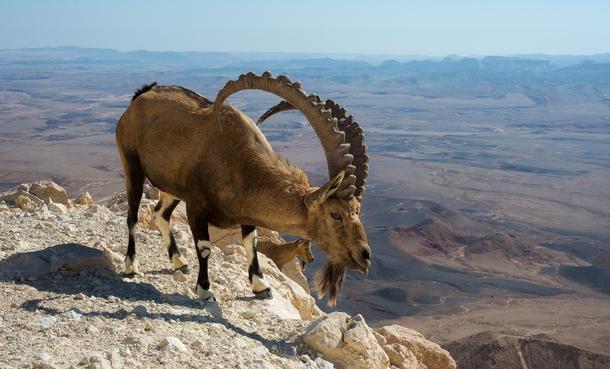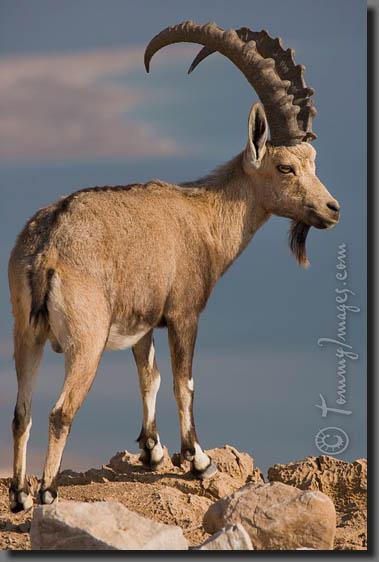The first image is the image on the left, the second image is the image on the right. Analyze the images presented: Is the assertion "There are several goats visible in each set; much more than two." valid? Answer yes or no. No. The first image is the image on the left, the second image is the image on the right. For the images displayed, is the sentence "At least one big horn sheep is looking down over the edge of a tall cliff." factually correct? Answer yes or no. Yes. 